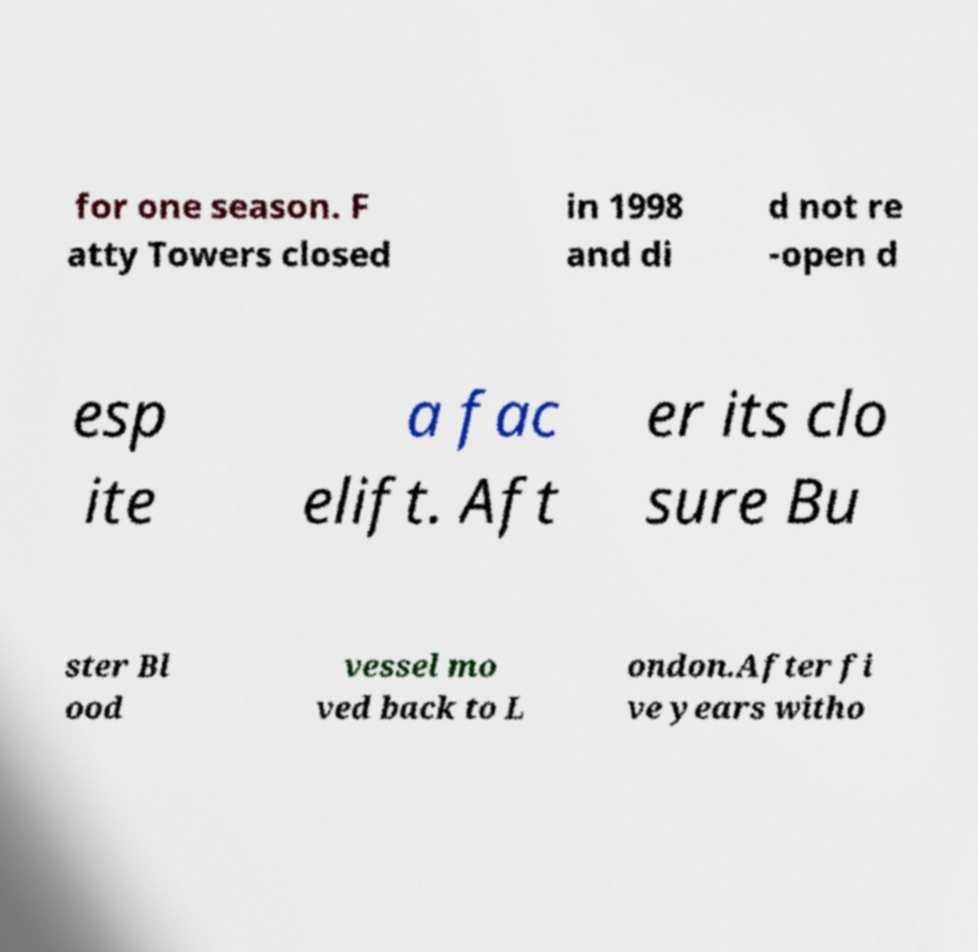For documentation purposes, I need the text within this image transcribed. Could you provide that? for one season. F atty Towers closed in 1998 and di d not re -open d esp ite a fac elift. Aft er its clo sure Bu ster Bl ood vessel mo ved back to L ondon.After fi ve years witho 